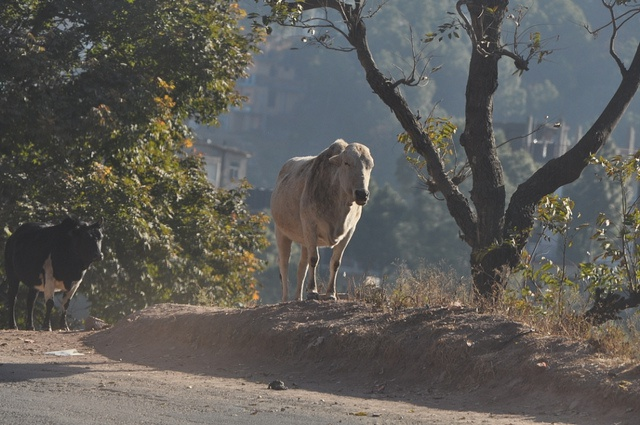Describe the objects in this image and their specific colors. I can see cow in black and gray tones and cow in black and gray tones in this image. 